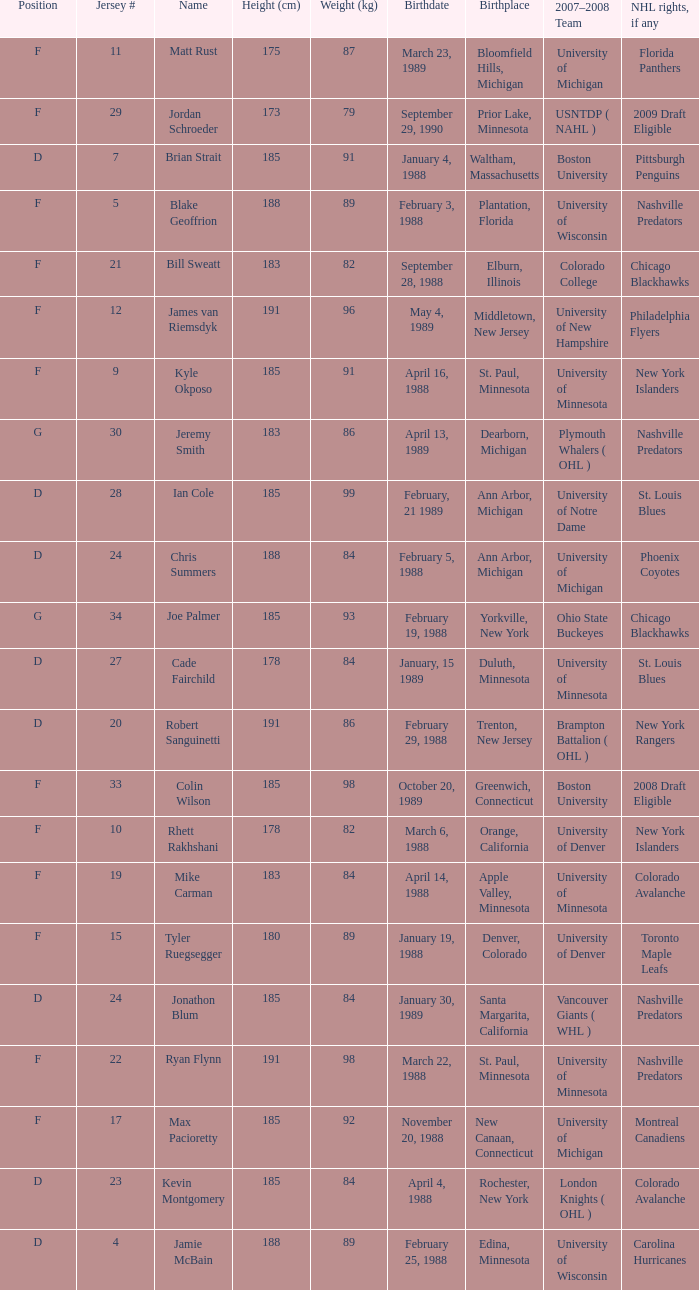Which Height (cm) has a Birthplace of bloomfield hills, michigan? 175.0. 